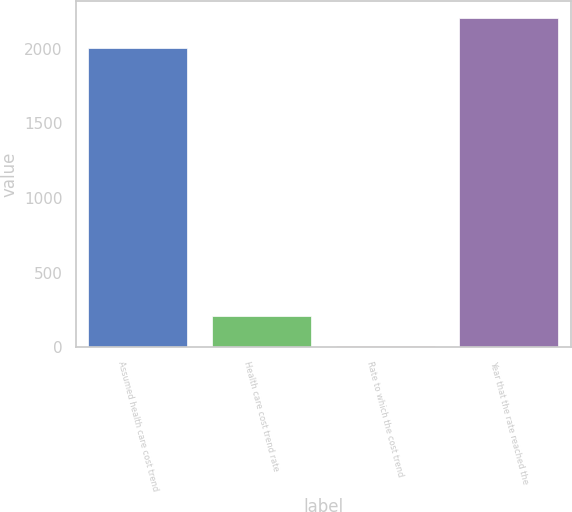Convert chart to OTSL. <chart><loc_0><loc_0><loc_500><loc_500><bar_chart><fcel>Assumed health care cost trend<fcel>Health care cost trend rate<fcel>Rate to which the cost trend<fcel>Year that the rate reached the<nl><fcel>2007<fcel>206<fcel>5<fcel>2208<nl></chart> 